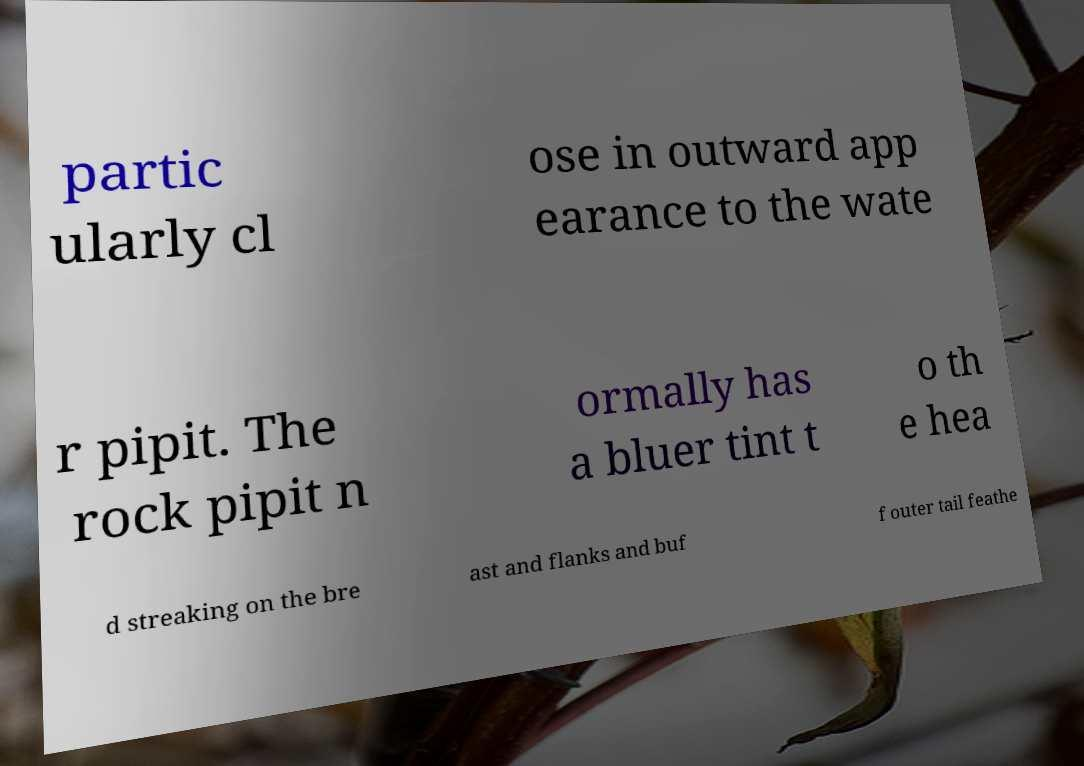Can you accurately transcribe the text from the provided image for me? partic ularly cl ose in outward app earance to the wate r pipit. The rock pipit n ormally has a bluer tint t o th e hea d streaking on the bre ast and flanks and buf f outer tail feathe 